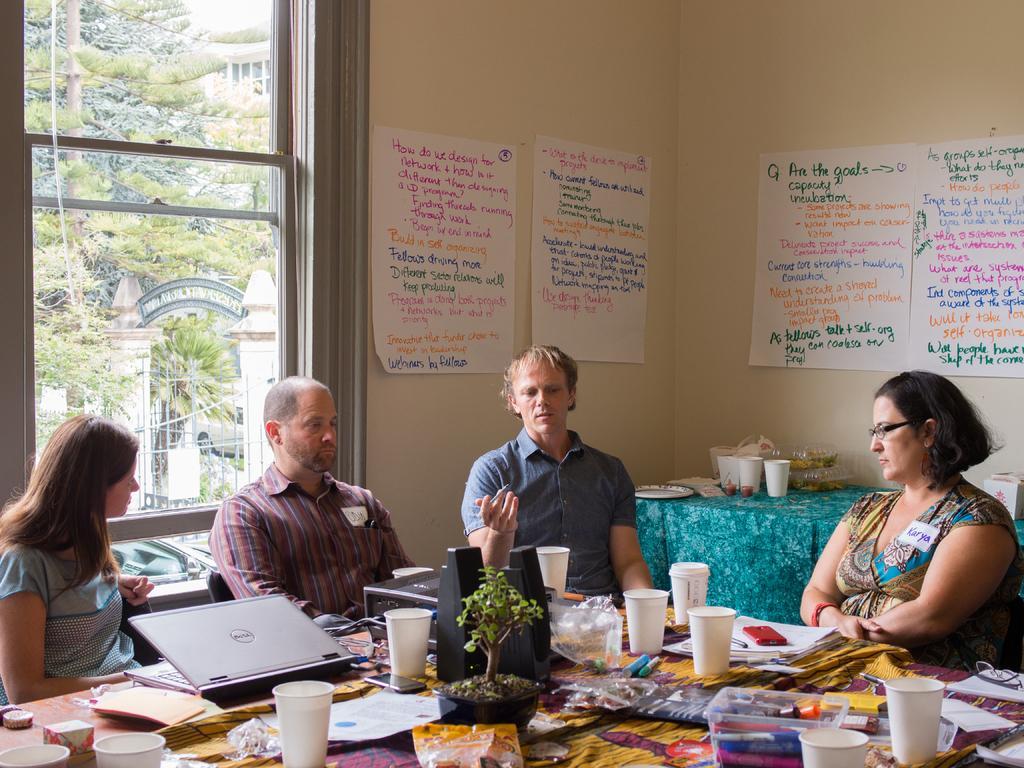How would you summarize this image in a sentence or two? In this picture we can see two men and two women sitting on chair and talking to each other and in front of them there is table and on table we can see glasses, box, flower pot with plant, laptop, papers, spectacle, mobile, cover and in background we can see wall with posters, window and from window tree. 